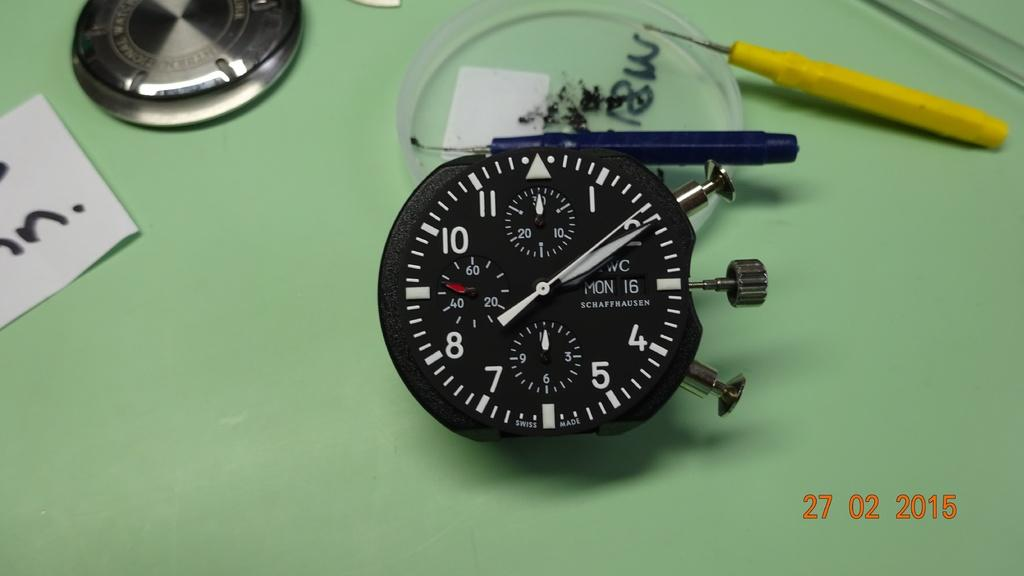<image>
Create a compact narrative representing the image presented. A time piece that has 'Swiss made' on it has the time at 8:10. 